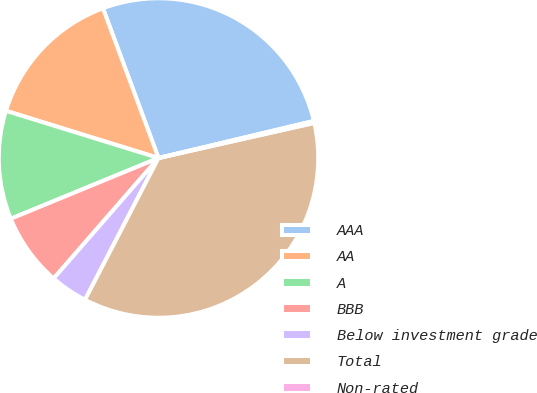Convert chart to OTSL. <chart><loc_0><loc_0><loc_500><loc_500><pie_chart><fcel>AAA<fcel>AA<fcel>A<fcel>BBB<fcel>Below investment grade<fcel>Total<fcel>Non-rated<nl><fcel>26.93%<fcel>14.57%<fcel>10.98%<fcel>7.39%<fcel>3.79%<fcel>36.14%<fcel>0.2%<nl></chart> 